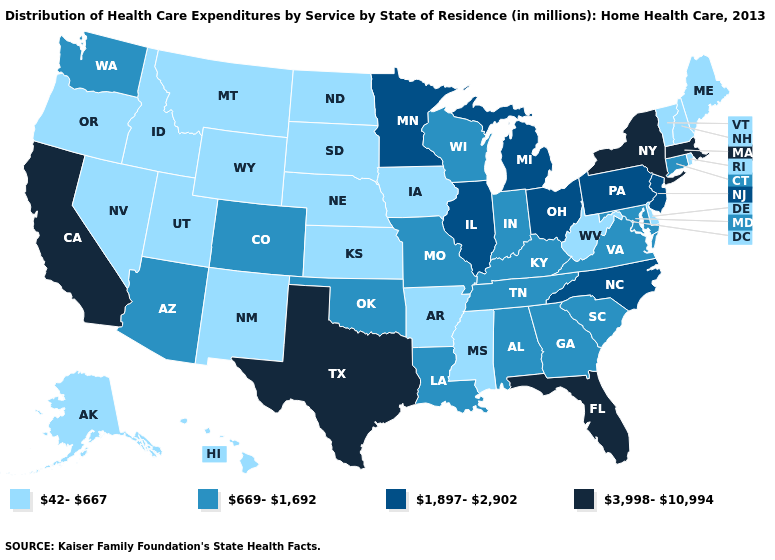Does Kentucky have the lowest value in the South?
Write a very short answer. No. Does Vermont have the highest value in the Northeast?
Quick response, please. No. Does Idaho have a lower value than West Virginia?
Be succinct. No. Name the states that have a value in the range 669-1,692?
Keep it brief. Alabama, Arizona, Colorado, Connecticut, Georgia, Indiana, Kentucky, Louisiana, Maryland, Missouri, Oklahoma, South Carolina, Tennessee, Virginia, Washington, Wisconsin. Name the states that have a value in the range 669-1,692?
Quick response, please. Alabama, Arizona, Colorado, Connecticut, Georgia, Indiana, Kentucky, Louisiana, Maryland, Missouri, Oklahoma, South Carolina, Tennessee, Virginia, Washington, Wisconsin. Does Ohio have the highest value in the MidWest?
Quick response, please. Yes. Name the states that have a value in the range 669-1,692?
Give a very brief answer. Alabama, Arizona, Colorado, Connecticut, Georgia, Indiana, Kentucky, Louisiana, Maryland, Missouri, Oklahoma, South Carolina, Tennessee, Virginia, Washington, Wisconsin. What is the lowest value in states that border Connecticut?
Write a very short answer. 42-667. Which states have the lowest value in the USA?
Give a very brief answer. Alaska, Arkansas, Delaware, Hawaii, Idaho, Iowa, Kansas, Maine, Mississippi, Montana, Nebraska, Nevada, New Hampshire, New Mexico, North Dakota, Oregon, Rhode Island, South Dakota, Utah, Vermont, West Virginia, Wyoming. Among the states that border Maryland , which have the highest value?
Give a very brief answer. Pennsylvania. What is the value of Ohio?
Concise answer only. 1,897-2,902. Among the states that border Maine , which have the lowest value?
Short answer required. New Hampshire. Name the states that have a value in the range 1,897-2,902?
Short answer required. Illinois, Michigan, Minnesota, New Jersey, North Carolina, Ohio, Pennsylvania. Name the states that have a value in the range 669-1,692?
Be succinct. Alabama, Arizona, Colorado, Connecticut, Georgia, Indiana, Kentucky, Louisiana, Maryland, Missouri, Oklahoma, South Carolina, Tennessee, Virginia, Washington, Wisconsin. Does Kentucky have a lower value than Kansas?
Write a very short answer. No. 